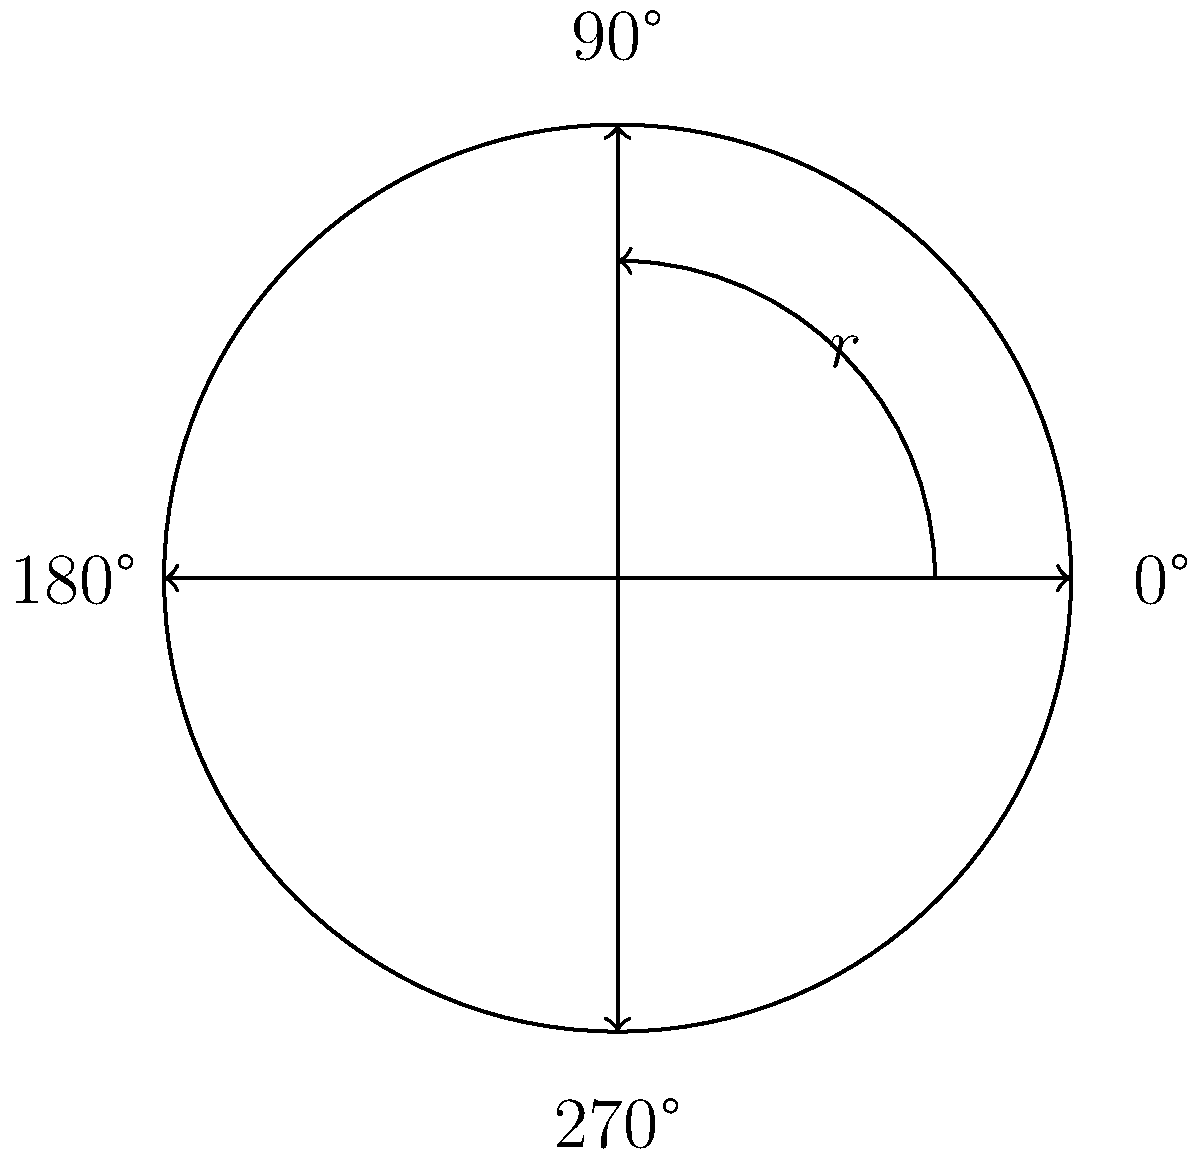You and your classmate are discussing the rotation group of a vinyl record player. If the turntable rotates 90° clockwise, then 180° counterclockwise, and finally 270° clockwise, what is the resulting rotation in terms of the smallest positive angle? Let's approach this step-by-step:

1) First, let's assign positive values to clockwise rotations and negative values to counterclockwise rotations.

2) Now, let's break down the rotations:
   - 90° clockwise: +90°
   - 180° counterclockwise: -180°
   - 270° clockwise: +270°

3) Let's add these rotations:
   $$(+90°) + (-180°) + (+270°) = 180°$$

4) In the rotation group of a circle, we consider rotations modulo 360°. 180° is already the smallest positive angle that represents this rotation.

5) Therefore, the final rotation is equivalent to a 180° rotation clockwise (or counterclockwise, as they're the same for 180°).

This problem demonstrates the non-commutative nature of the rotation group, as the order of rotations matters, and how multiple rotations can be combined into a single, equivalent rotation.
Answer: 180° 